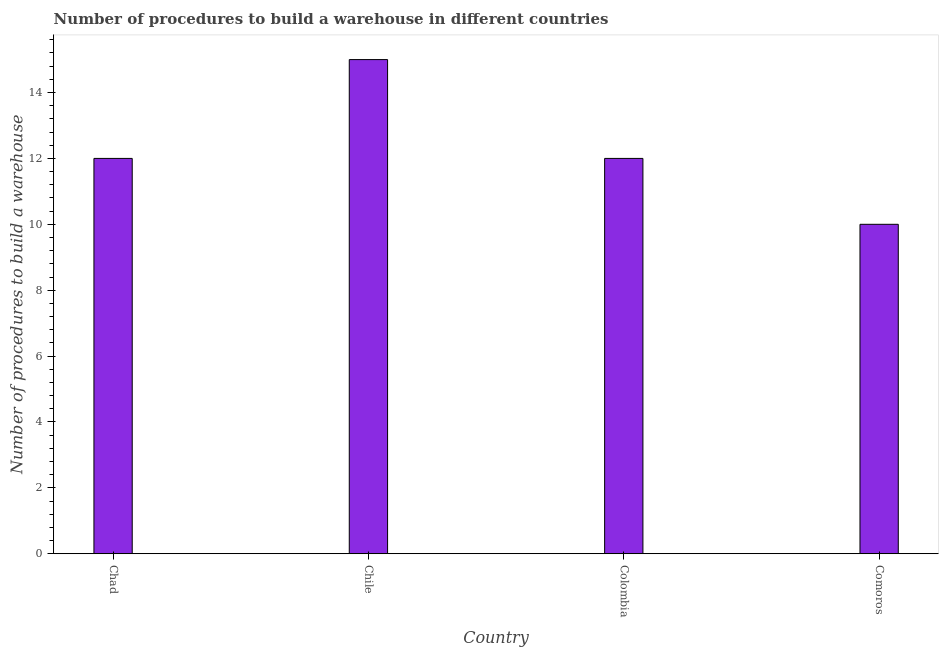What is the title of the graph?
Provide a succinct answer. Number of procedures to build a warehouse in different countries. What is the label or title of the Y-axis?
Your response must be concise. Number of procedures to build a warehouse. What is the number of procedures to build a warehouse in Colombia?
Your answer should be compact. 12. Across all countries, what is the maximum number of procedures to build a warehouse?
Provide a succinct answer. 15. Across all countries, what is the minimum number of procedures to build a warehouse?
Ensure brevity in your answer.  10. In which country was the number of procedures to build a warehouse maximum?
Offer a very short reply. Chile. In which country was the number of procedures to build a warehouse minimum?
Your response must be concise. Comoros. What is the average number of procedures to build a warehouse per country?
Ensure brevity in your answer.  12.25. What is the median number of procedures to build a warehouse?
Your answer should be very brief. 12. What is the ratio of the number of procedures to build a warehouse in Chad to that in Colombia?
Keep it short and to the point. 1. Is the number of procedures to build a warehouse in Chad less than that in Colombia?
Offer a terse response. No. Is the difference between the number of procedures to build a warehouse in Chad and Comoros greater than the difference between any two countries?
Provide a short and direct response. No. Is the sum of the number of procedures to build a warehouse in Chad and Colombia greater than the maximum number of procedures to build a warehouse across all countries?
Your answer should be very brief. Yes. Are all the bars in the graph horizontal?
Your response must be concise. No. How many countries are there in the graph?
Provide a short and direct response. 4. What is the difference between two consecutive major ticks on the Y-axis?
Provide a succinct answer. 2. What is the Number of procedures to build a warehouse in Colombia?
Your response must be concise. 12. What is the difference between the Number of procedures to build a warehouse in Chad and Chile?
Your response must be concise. -3. What is the difference between the Number of procedures to build a warehouse in Chile and Colombia?
Give a very brief answer. 3. What is the difference between the Number of procedures to build a warehouse in Chile and Comoros?
Offer a terse response. 5. What is the ratio of the Number of procedures to build a warehouse in Chad to that in Comoros?
Give a very brief answer. 1.2. What is the ratio of the Number of procedures to build a warehouse in Chile to that in Colombia?
Your answer should be very brief. 1.25. What is the ratio of the Number of procedures to build a warehouse in Chile to that in Comoros?
Provide a succinct answer. 1.5. 